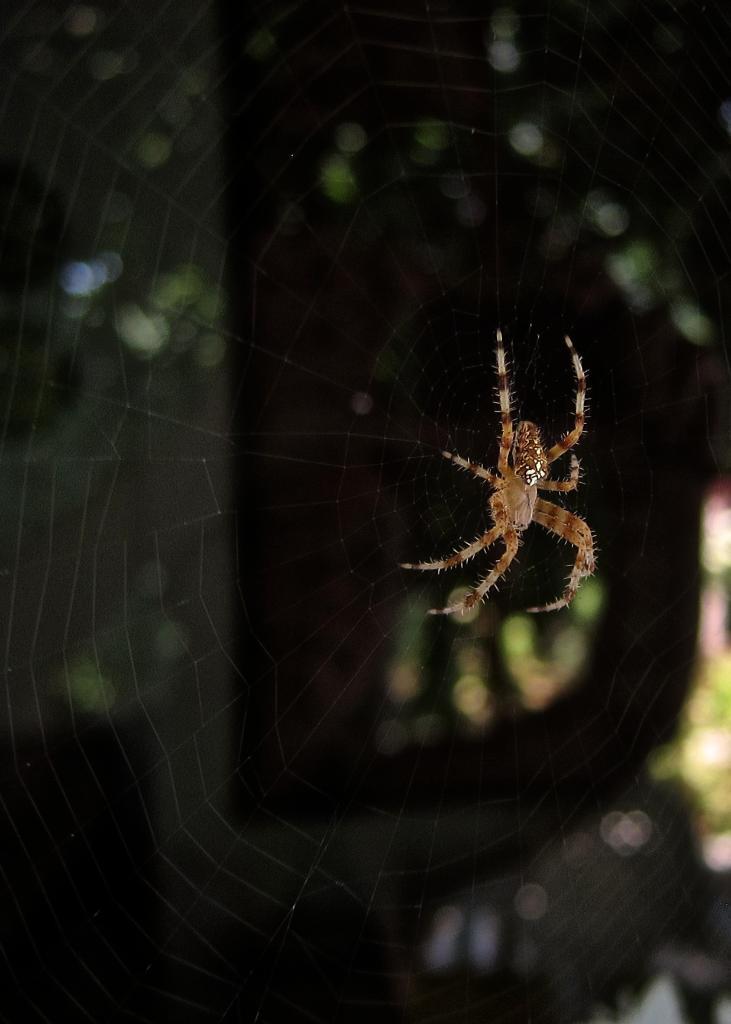How would you summarize this image in a sentence or two? In this image, we can see a spider on the web which is on the blur background. 